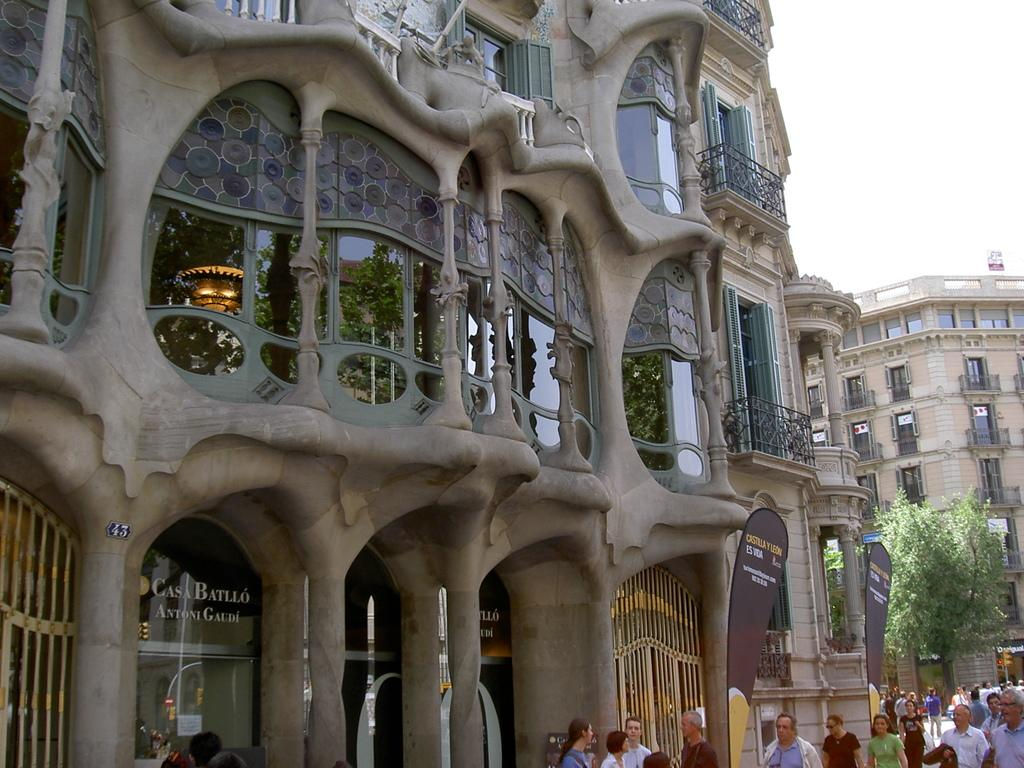Who or what can be seen at the bottom of the image? There are persons at the bottom of the image. What type of structures are visible in the background? There are buildings in the background of the image. What architectural features can be seen in the background? There are windows, glass doors, and hoardings in the background of the image. What type of vegetation is visible in the background? There are trees in the background of the image. What type of barrier is present in the background? There are fences in the background of the image. What part of the natural environment is visible in the background? The sky is visible in the background of the image. How many trousers are hanging on the hoardings in the image? There are no trousers present in the image, and therefore no such items can be counted. 